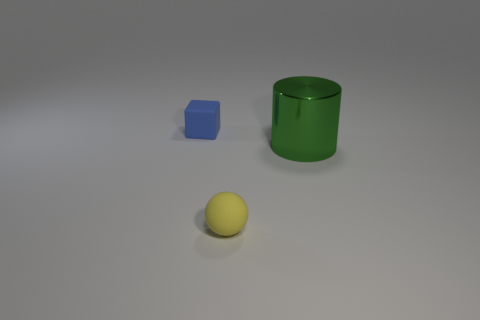Is there anything else that is the same material as the large cylinder?
Your answer should be very brief. No. Is there a big object behind the tiny thing that is behind the thing on the right side of the small yellow ball?
Provide a succinct answer. No. Are there more metal things that are in front of the blue rubber object than balls that are behind the tiny yellow matte thing?
Your response must be concise. Yes. There is a yellow sphere that is the same size as the blue matte object; what material is it?
Provide a short and direct response. Rubber. How many large things are green metal objects or yellow matte objects?
Provide a succinct answer. 1. Do the yellow matte thing and the green thing have the same shape?
Your answer should be very brief. No. How many things are on the left side of the green shiny cylinder and behind the tiny yellow sphere?
Keep it short and to the point. 1. Is there anything else that is the same color as the big shiny cylinder?
Keep it short and to the point. No. The tiny blue object that is made of the same material as the yellow ball is what shape?
Keep it short and to the point. Cube. Is the yellow matte sphere the same size as the blue rubber thing?
Keep it short and to the point. Yes. 